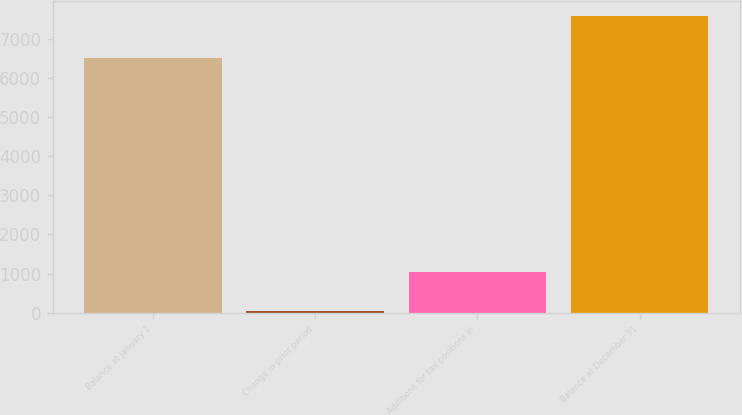Convert chart. <chart><loc_0><loc_0><loc_500><loc_500><bar_chart><fcel>Balance at January 1<fcel>Change in prior period<fcel>Additions for tax positions in<fcel>Balance at December 31<nl><fcel>6494<fcel>33<fcel>1052<fcel>7579<nl></chart> 